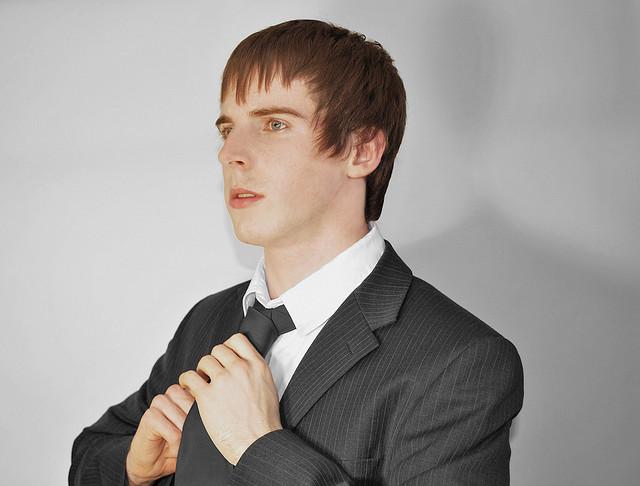How many ears do you see on the man?
Write a very short answer. 1. What color is the tie?
Give a very brief answer. Gray. Is the man wearing any jewelry?
Answer briefly. No. How does he tell time?
Quick response, please. Watch. What color is his tie?
Give a very brief answer. Black. Is this man wearing a tie?
Write a very short answer. Yes. What color is his necktie?
Keep it brief. Black. Is anyone wearing cufflinks?
Be succinct. No. How many people are in the pic?
Quick response, please. 1. Does this man need to comb his hair?
Write a very short answer. No. What color is this man's shirt?
Write a very short answer. White. What is the man looking at?
Concise answer only. Distance. Is this a man or a woman?
Give a very brief answer. Man. Does this man need a haircut soon?
Short answer required. Yes. 